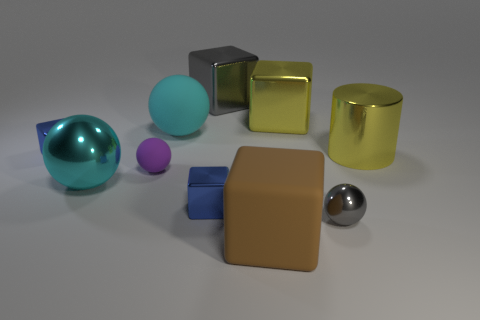Subtract all tiny blue metallic blocks. How many blocks are left? 3 Subtract all brown blocks. How many blocks are left? 4 Subtract all cylinders. How many objects are left? 9 Subtract 1 cylinders. How many cylinders are left? 0 Subtract 0 green spheres. How many objects are left? 10 Subtract all blue blocks. Subtract all red cylinders. How many blocks are left? 3 Subtract all cyan cylinders. How many green spheres are left? 0 Subtract all small blue metal things. Subtract all cyan rubber balls. How many objects are left? 7 Add 4 large yellow cylinders. How many large yellow cylinders are left? 5 Add 7 gray objects. How many gray objects exist? 9 